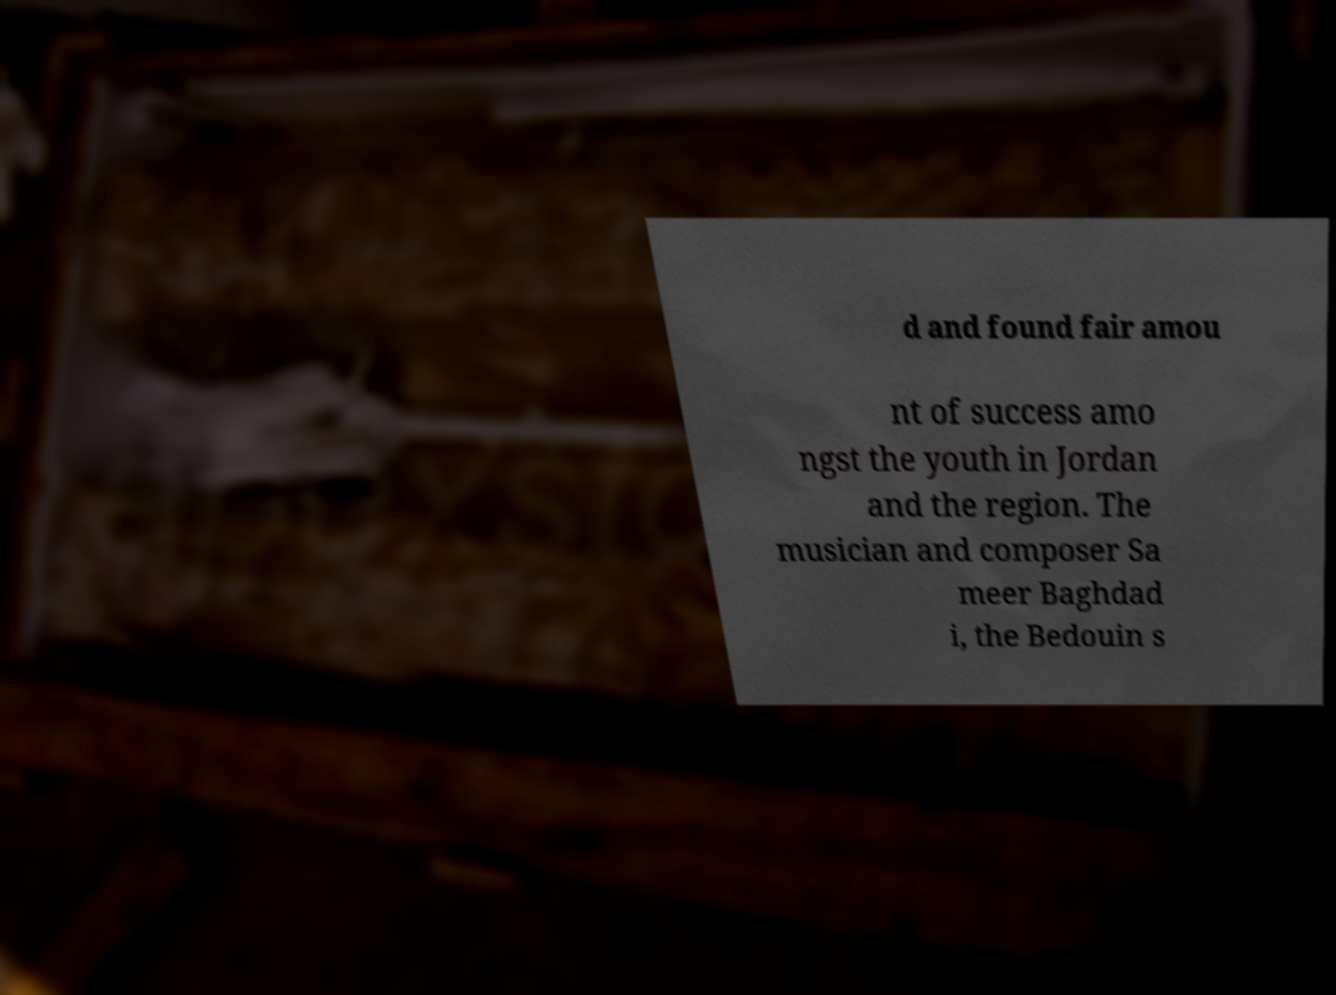There's text embedded in this image that I need extracted. Can you transcribe it verbatim? d and found fair amou nt of success amo ngst the youth in Jordan and the region. The musician and composer Sa meer Baghdad i, the Bedouin s 